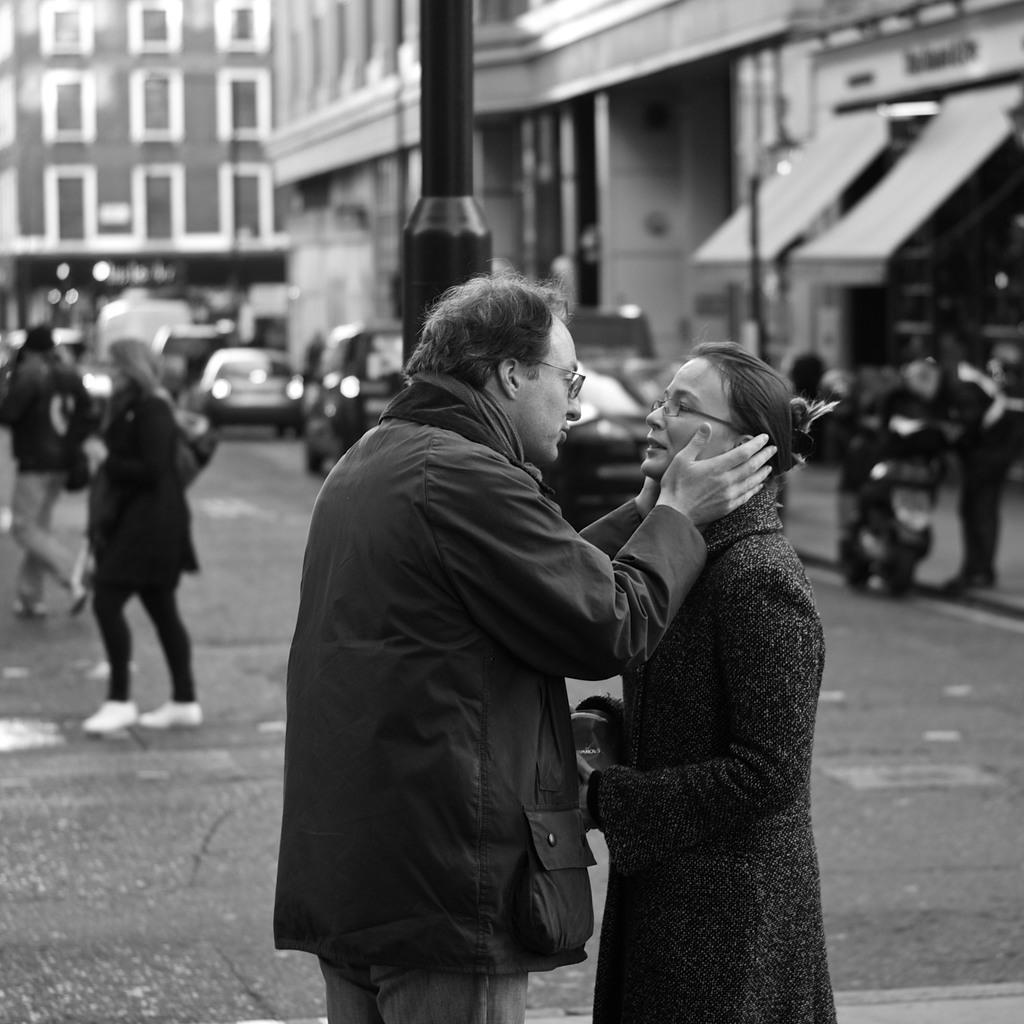Who or what can be seen in the image? There are people in the image. What else is present in the image besides people? There are vehicles on the road and a pole in the image. What can be seen in the background of the image? There are buildings in the background of the image. What type of organization is depicted in the image? There is no organization depicted in the image; it features people, vehicles, a pole, and buildings in the background. Can you tell me how many bats are flying in the image? There are no bats present in the image. 